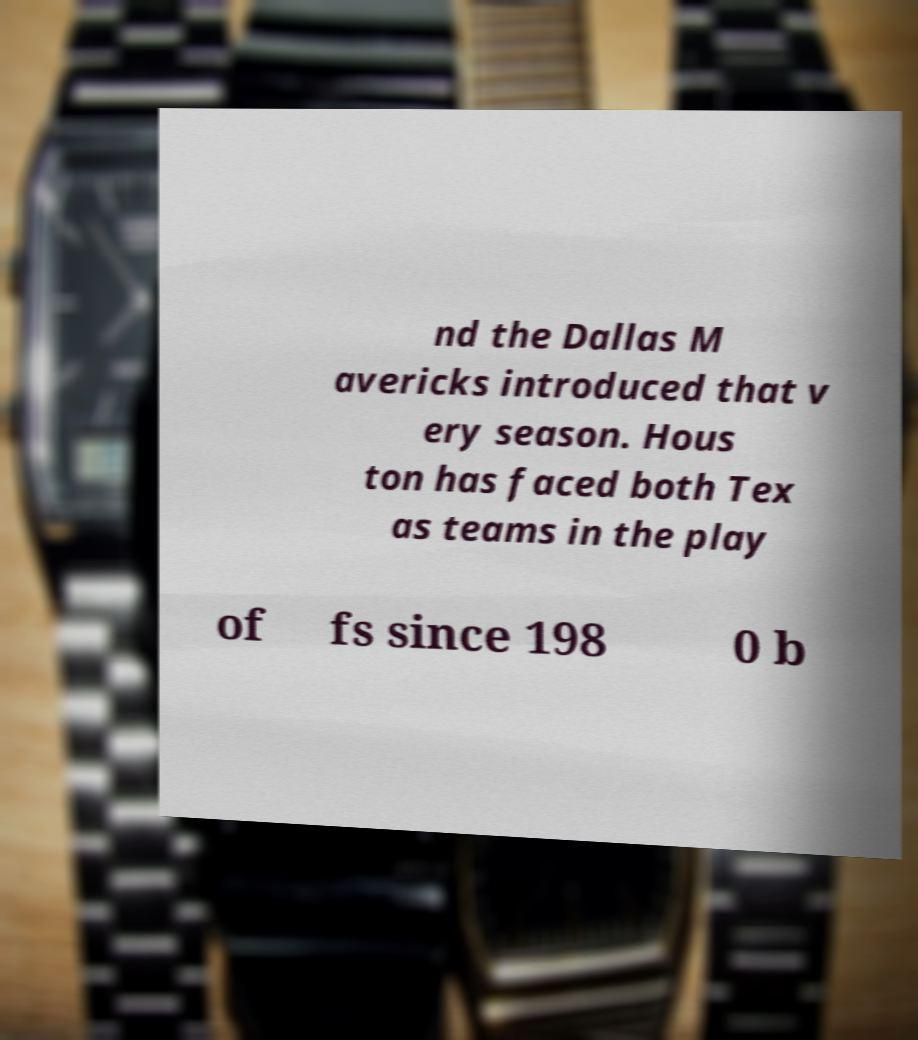I need the written content from this picture converted into text. Can you do that? nd the Dallas M avericks introduced that v ery season. Hous ton has faced both Tex as teams in the play of fs since 198 0 b 